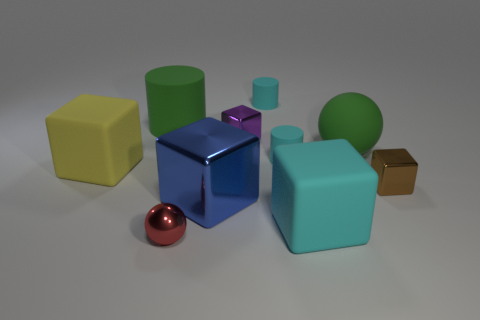Are there more small red metal balls to the right of the large blue thing than small cyan matte cylinders? Upon careful observation of the image, it appears that to the right of the large reflective blue cube, there is only one small red metal ball. In comparison, there aren't any small cyan matte cylinders in that specific area, making the count of red metal balls greater, albeit by default as there are none of the latter to compare with. 